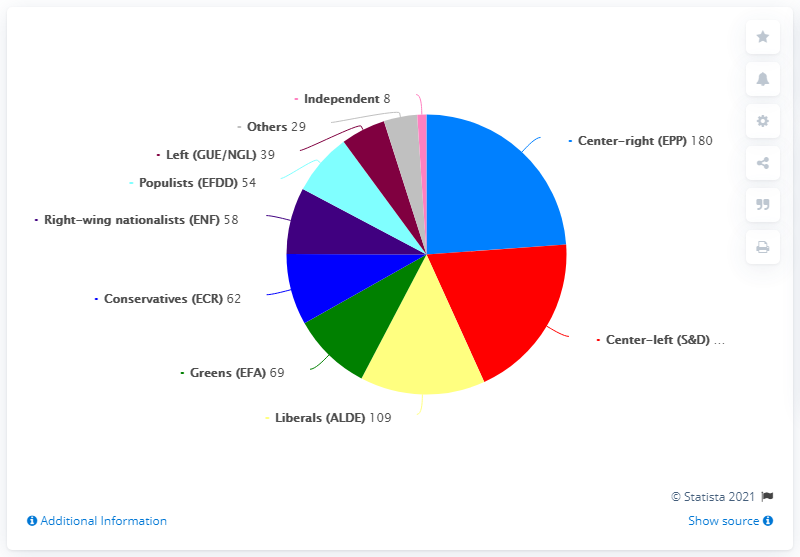Outline some significant characteristics in this image. The difference between Conservatives and Greens is that Conservatives prioritize limiting government intervention, economic freedom, and individual rights, while Greens prioritize environmental protection, social justice, and economic sustainability. The color pink represents independence. 